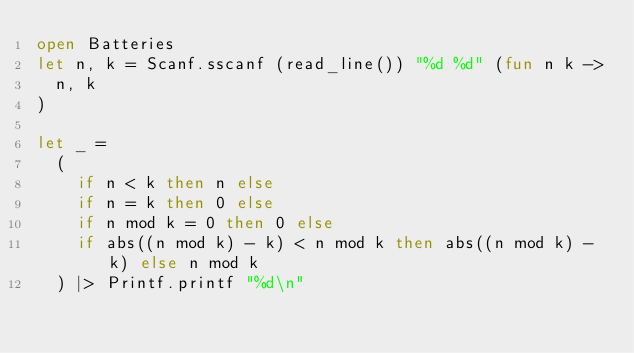Convert code to text. <code><loc_0><loc_0><loc_500><loc_500><_OCaml_>open Batteries
let n, k = Scanf.sscanf (read_line()) "%d %d" (fun n k ->
  n, k
)

let _ = 
  (
    if n < k then n else
    if n = k then 0 else
    if n mod k = 0 then 0 else
    if abs((n mod k) - k) < n mod k then abs((n mod k) - k) else n mod k
  ) |> Printf.printf "%d\n"</code> 